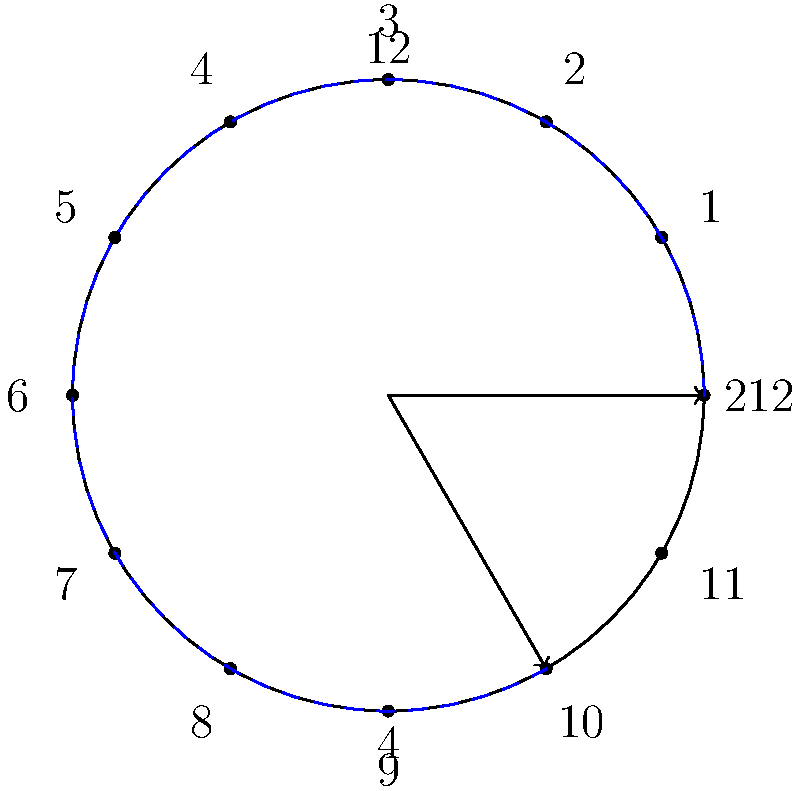In the context of time dilation in aging theories, a clock face is rotated to represent the slowing of time. If the hour hand moves from 12 to 2 in the reference frame of a stationary observer, what would be the corresponding time in a reference frame experiencing significant time dilation if the clock appears rotated 60° clockwise? To solve this problem, we need to follow these steps:

1) In the stationary reference frame, the movement from 12 to 2 represents 2 hours or 60 degrees of rotation (as there are 360° in a full circle and 12 hours, so each hour represents 30°).

2) The clock in the time-dilated frame appears rotated 60° clockwise. This means we need to subtract 60° from the final position of the hour hand in the stationary frame.

3) The final position in the stationary frame is at 2 o'clock, which is 60° from 12 o'clock.

4) Subtracting the 60° rotation: 60° - 60° = 0°

5) 0° corresponds to 12 o'clock on the clock face.

6) Therefore, in the time-dilated frame, when the stationary observer sees 2 hours pass, the clock would still show 12 o'clock.

This illustrates the concept of time dilation, where time appears to pass more slowly in the reference frame experiencing significant time dilation (such as one moving at very high speeds or in a strong gravitational field).
Answer: 12 o'clock 